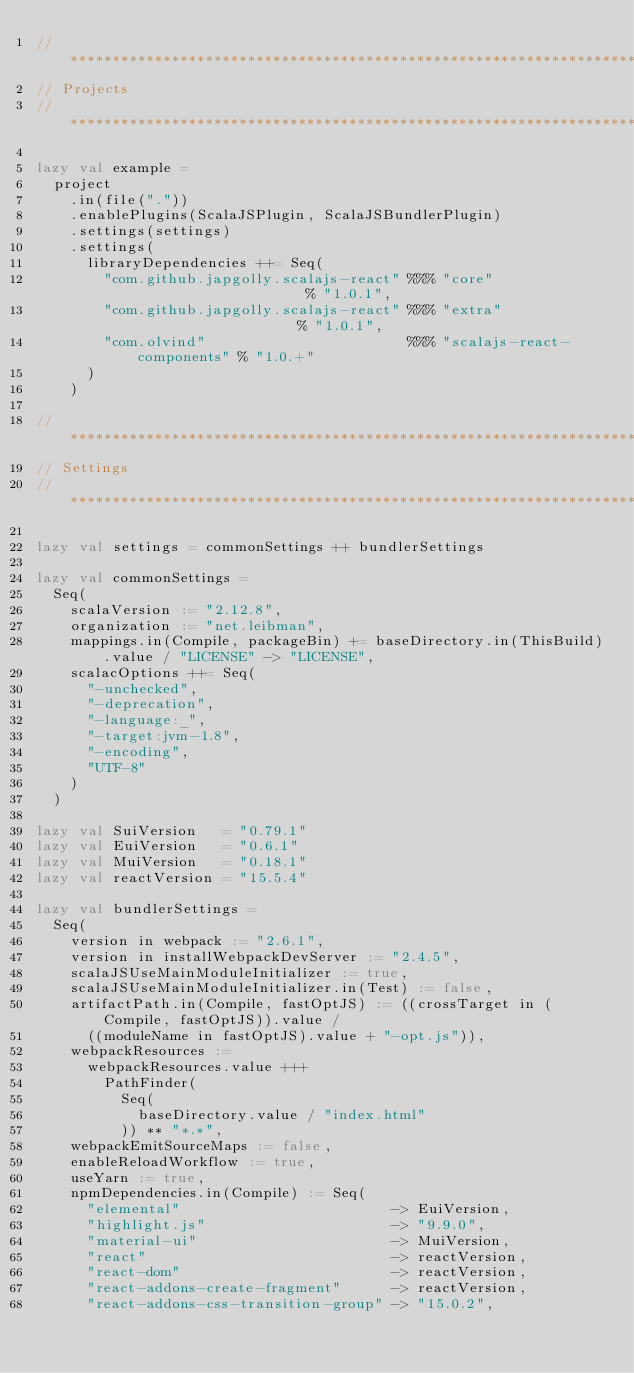<code> <loc_0><loc_0><loc_500><loc_500><_Scala_>// *****************************************************************************
// Projects
// *****************************************************************************

lazy val example =
  project
    .in(file("."))
    .enablePlugins(ScalaJSPlugin, ScalaJSBundlerPlugin)
    .settings(settings)
    .settings(
      libraryDependencies ++= Seq(
        "com.github.japgolly.scalajs-react" %%% "core"                     % "1.0.1",
        "com.github.japgolly.scalajs-react" %%% "extra"                    % "1.0.1",
        "com.olvind"                        %%% "scalajs-react-components" % "1.0.+"
      )
    )

// *****************************************************************************
// Settings
// *****************************************************************************

lazy val settings = commonSettings ++ bundlerSettings

lazy val commonSettings =
  Seq(
    scalaVersion := "2.12.8",
    organization := "net.leibman",
    mappings.in(Compile, packageBin) += baseDirectory.in(ThisBuild).value / "LICENSE" -> "LICENSE",
    scalacOptions ++= Seq(
      "-unchecked",
      "-deprecation",
      "-language:_",
      "-target:jvm-1.8",
      "-encoding",
      "UTF-8"
    )
  )

lazy val SuiVersion   = "0.79.1"
lazy val EuiVersion   = "0.6.1"
lazy val MuiVersion   = "0.18.1"
lazy val reactVersion = "15.5.4"

lazy val bundlerSettings =
  Seq(
    version in webpack := "2.6.1",
    version in installWebpackDevServer := "2.4.5",
    scalaJSUseMainModuleInitializer := true,
    scalaJSUseMainModuleInitializer.in(Test) := false,
    artifactPath.in(Compile, fastOptJS) := ((crossTarget in (Compile, fastOptJS)).value /
      ((moduleName in fastOptJS).value + "-opt.js")),
    webpackResources :=
      webpackResources.value +++
        PathFinder(
          Seq(
            baseDirectory.value / "index.html"
          )) ** "*.*",
    webpackEmitSourceMaps := false,
    enableReloadWorkflow := true,
    useYarn := true,
    npmDependencies.in(Compile) := Seq(
      "elemental"                         -> EuiVersion,
      "highlight.js"                      -> "9.9.0",
      "material-ui"                       -> MuiVersion,
      "react"                             -> reactVersion,
      "react-dom"                         -> reactVersion,
      "react-addons-create-fragment"      -> reactVersion,
      "react-addons-css-transition-group" -> "15.0.2",</code> 